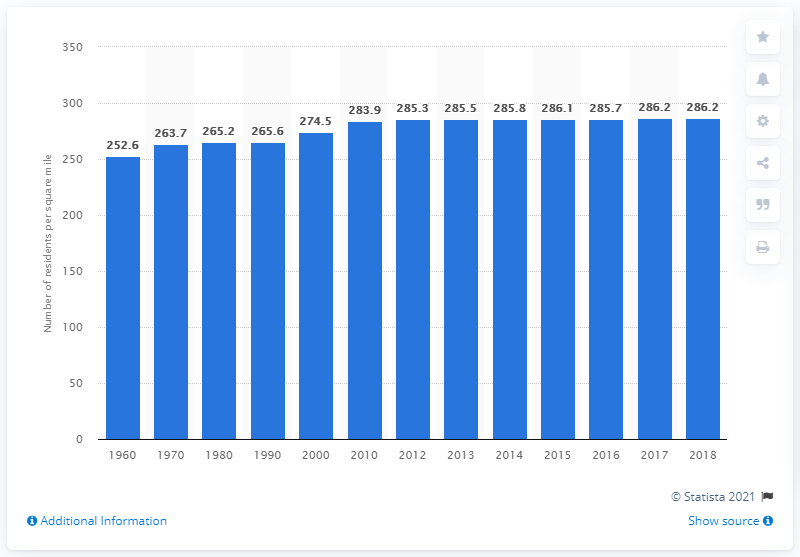List a handful of essential elements in this visual. In 2018, the population density of Pennsylvania was 286.2 people per square mile. 